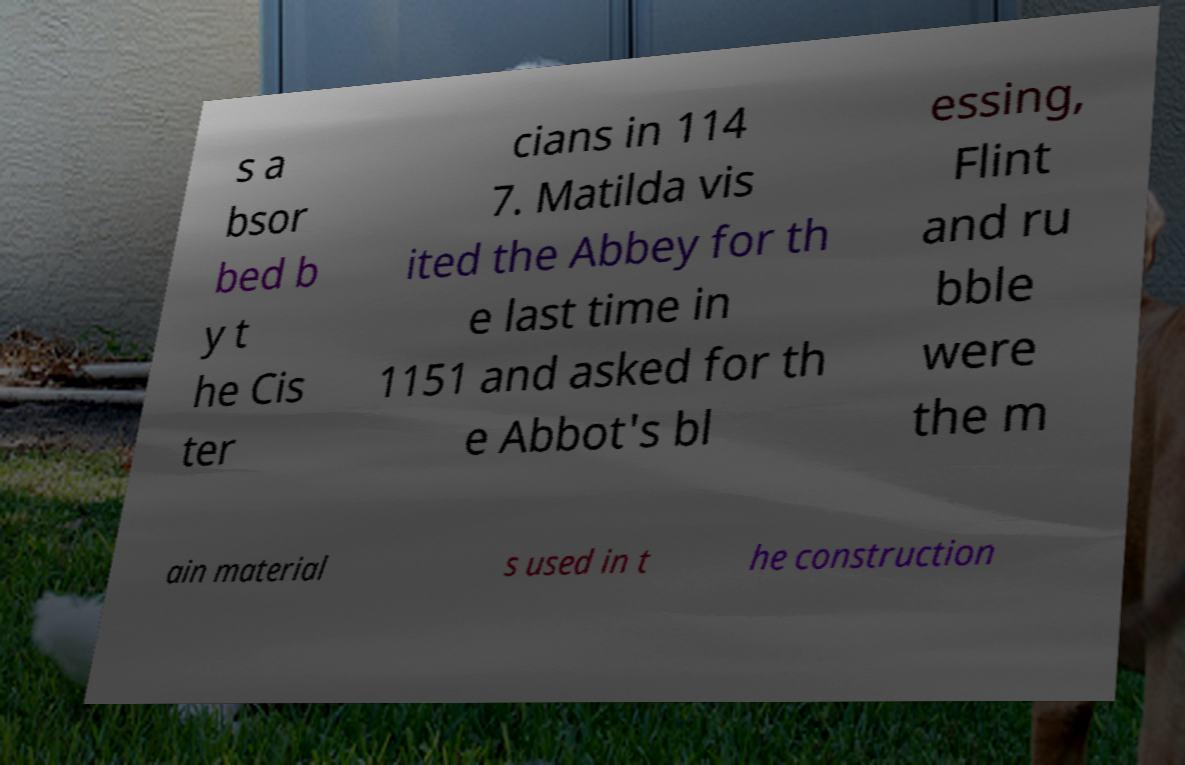Please read and relay the text visible in this image. What does it say? s a bsor bed b y t he Cis ter cians in 114 7. Matilda vis ited the Abbey for th e last time in 1151 and asked for th e Abbot's bl essing, Flint and ru bble were the m ain material s used in t he construction 